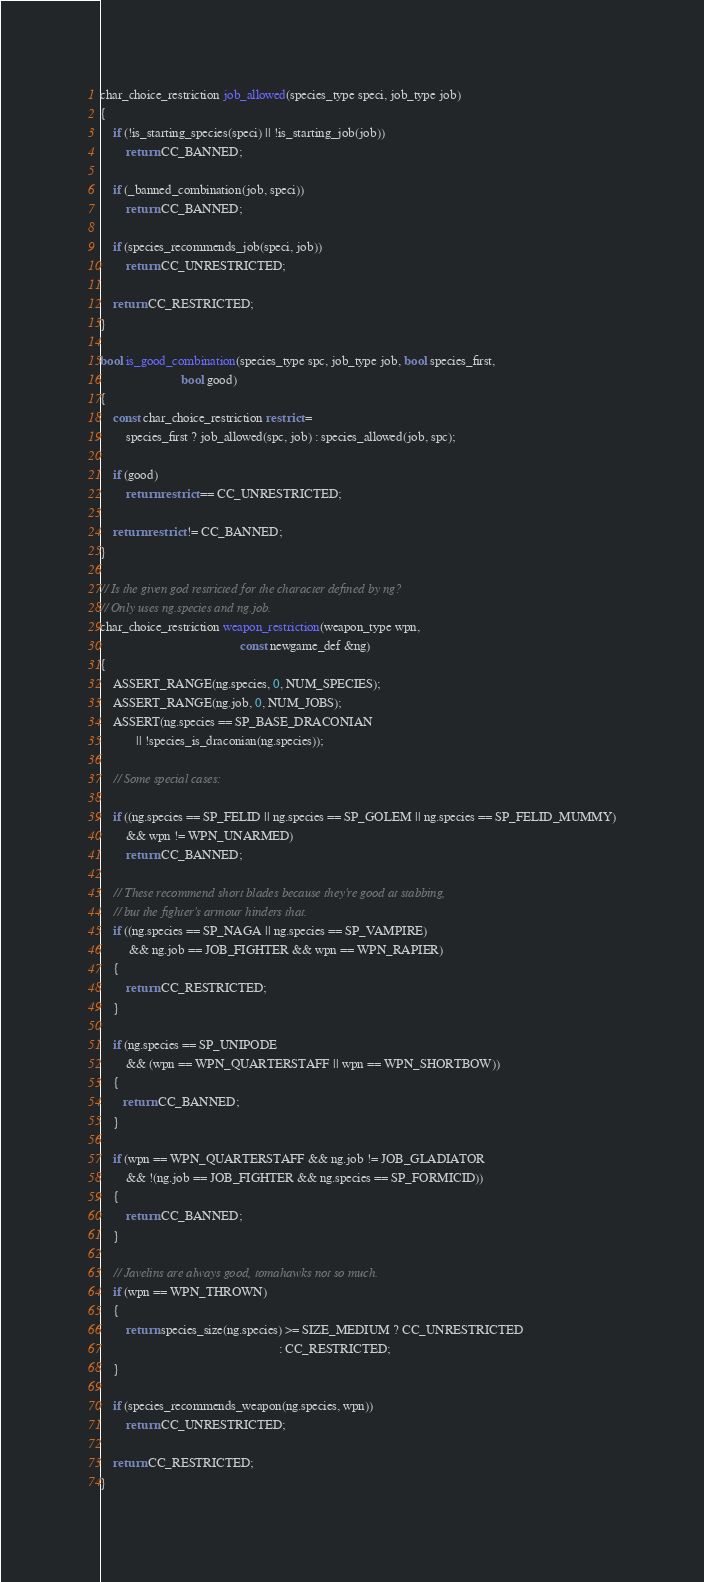<code> <loc_0><loc_0><loc_500><loc_500><_C++_>
char_choice_restriction job_allowed(species_type speci, job_type job)
{
    if (!is_starting_species(speci) || !is_starting_job(job))
        return CC_BANNED;

    if (_banned_combination(job, speci))
        return CC_BANNED;

    if (species_recommends_job(speci, job))
        return CC_UNRESTRICTED;

    return CC_RESTRICTED;
}

bool is_good_combination(species_type spc, job_type job, bool species_first,
                         bool good)
{
    const char_choice_restriction restrict =
        species_first ? job_allowed(spc, job) : species_allowed(job, spc);

    if (good)
        return restrict == CC_UNRESTRICTED;

    return restrict != CC_BANNED;
}

// Is the given god restricted for the character defined by ng?
// Only uses ng.species and ng.job.
char_choice_restriction weapon_restriction(weapon_type wpn,
                                           const newgame_def &ng)
{
    ASSERT_RANGE(ng.species, 0, NUM_SPECIES);
    ASSERT_RANGE(ng.job, 0, NUM_JOBS);
    ASSERT(ng.species == SP_BASE_DRACONIAN
           || !species_is_draconian(ng.species));

    // Some special cases:

    if ((ng.species == SP_FELID || ng.species == SP_GOLEM || ng.species == SP_FELID_MUMMY)
        && wpn != WPN_UNARMED)
        return CC_BANNED;

    // These recommend short blades because they're good at stabbing,
    // but the fighter's armour hinders that.
    if ((ng.species == SP_NAGA || ng.species == SP_VAMPIRE)
         && ng.job == JOB_FIGHTER && wpn == WPN_RAPIER)
    {
        return CC_RESTRICTED;
    }
	
    if (ng.species == SP_UNIPODE 
        && (wpn == WPN_QUARTERSTAFF || wpn == WPN_SHORTBOW))
    {
       return CC_BANNED;
    }

    if (wpn == WPN_QUARTERSTAFF && ng.job != JOB_GLADIATOR
        && !(ng.job == JOB_FIGHTER && ng.species == SP_FORMICID))
    {
        return CC_BANNED;
    }

    // Javelins are always good, tomahawks not so much.
    if (wpn == WPN_THROWN)
    {
        return species_size(ng.species) >= SIZE_MEDIUM ? CC_UNRESTRICTED
                                                       : CC_RESTRICTED;
    }

    if (species_recommends_weapon(ng.species, wpn))
        return CC_UNRESTRICTED;

    return CC_RESTRICTED;
}
</code> 